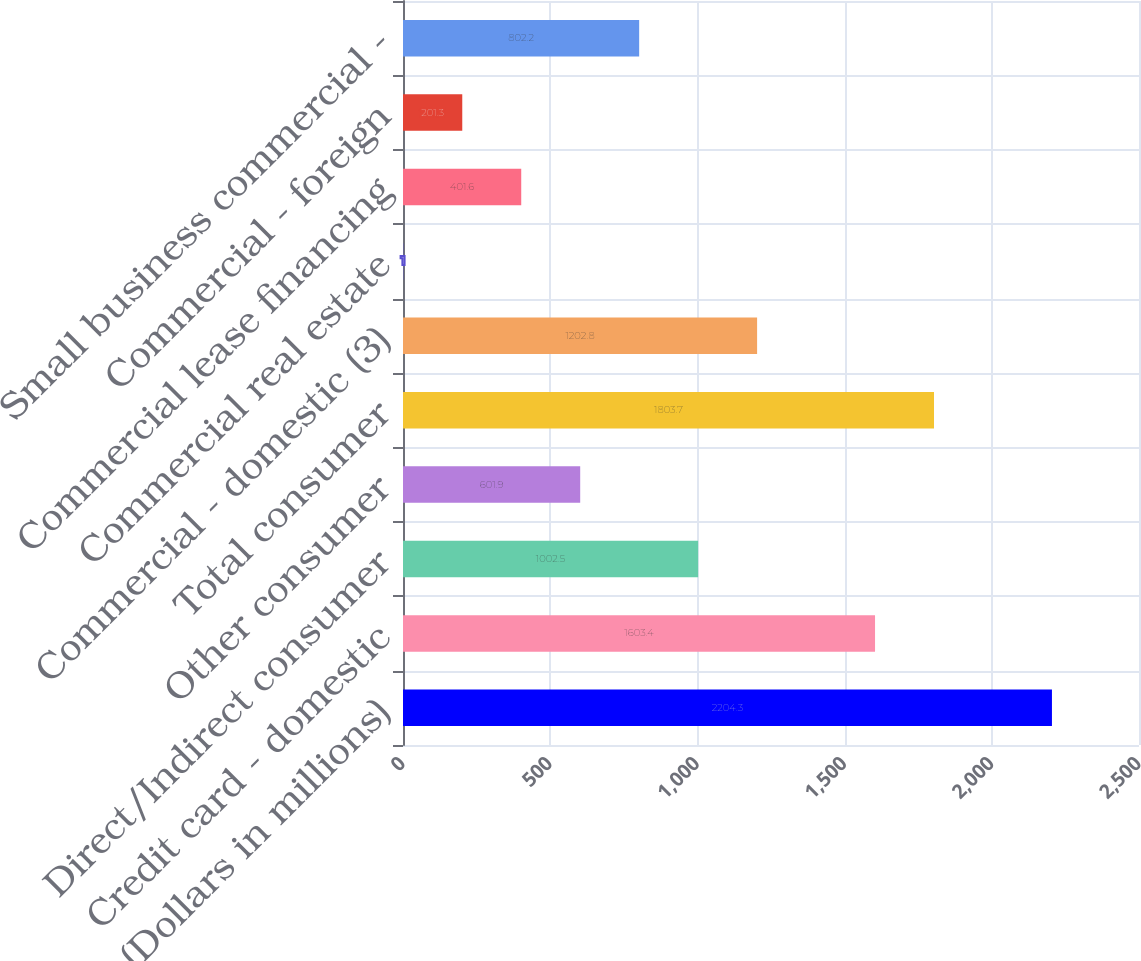Convert chart. <chart><loc_0><loc_0><loc_500><loc_500><bar_chart><fcel>(Dollars in millions)<fcel>Credit card - domestic<fcel>Direct/Indirect consumer<fcel>Other consumer<fcel>Total consumer<fcel>Commercial - domestic (3)<fcel>Commercial real estate<fcel>Commercial lease financing<fcel>Commercial - foreign<fcel>Small business commercial -<nl><fcel>2204.3<fcel>1603.4<fcel>1002.5<fcel>601.9<fcel>1803.7<fcel>1202.8<fcel>1<fcel>401.6<fcel>201.3<fcel>802.2<nl></chart> 